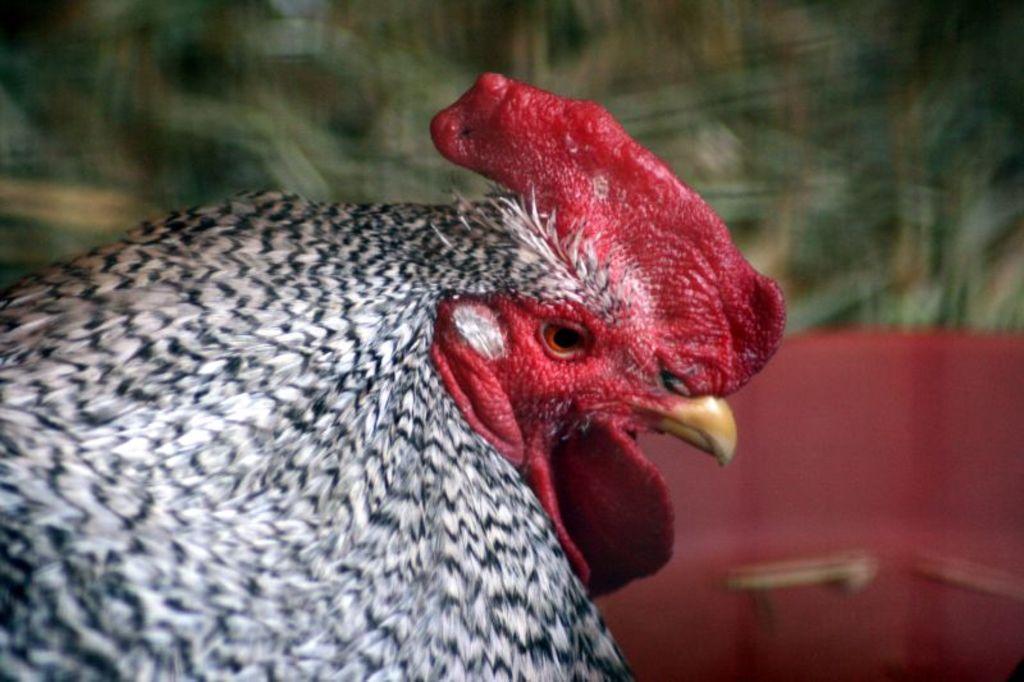Could you give a brief overview of what you see in this image? In this picture, we can see a hen and the blurred background. 